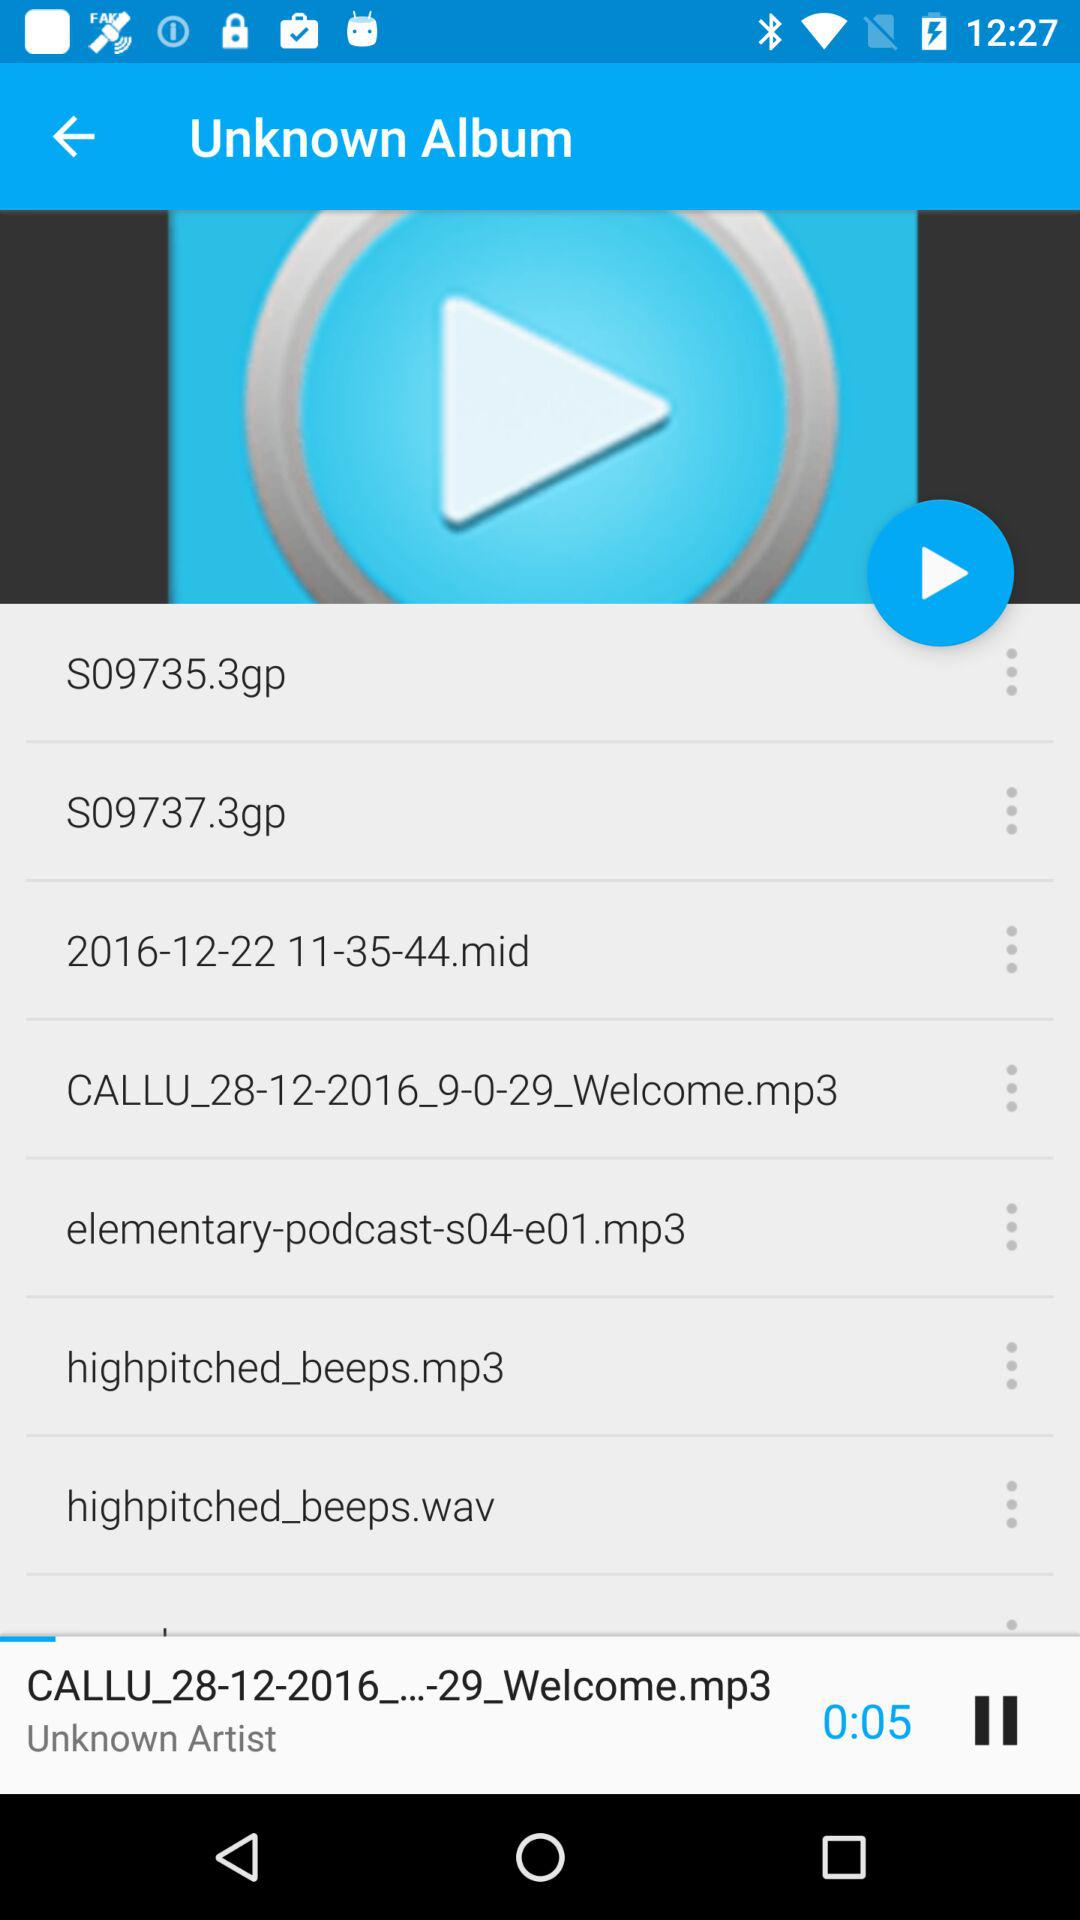Which album is playing? The album is "Unknown". 